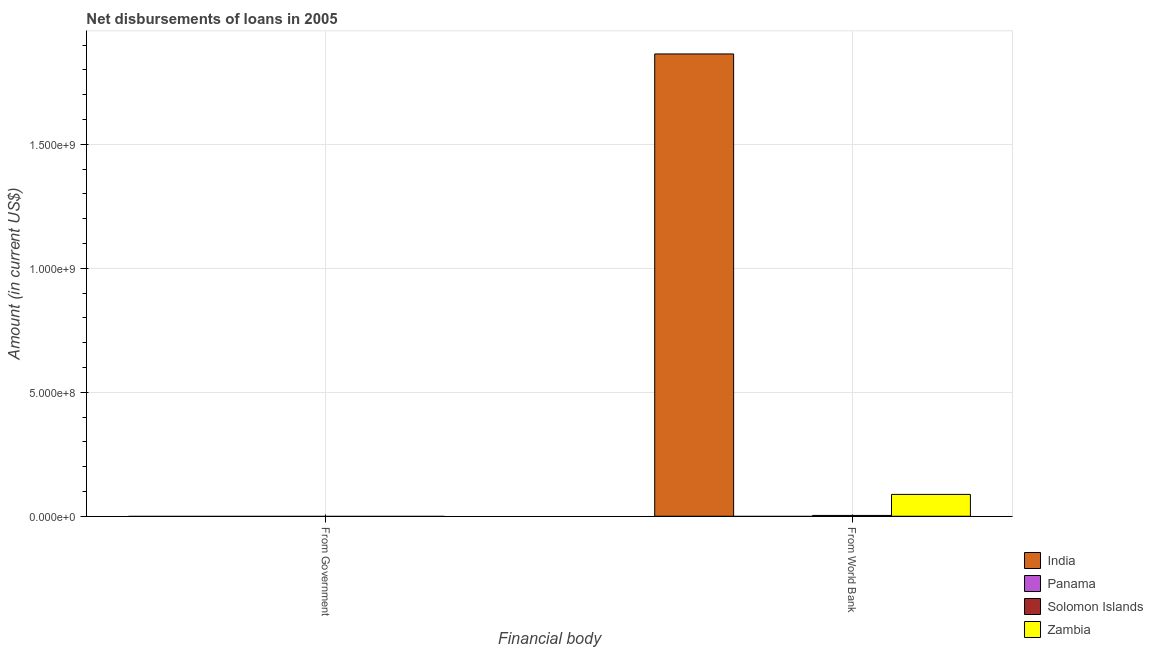How many different coloured bars are there?
Your answer should be compact. 3. Are the number of bars on each tick of the X-axis equal?
Your answer should be very brief. No. How many bars are there on the 1st tick from the left?
Provide a succinct answer. 0. What is the label of the 1st group of bars from the left?
Ensure brevity in your answer.  From Government. Across all countries, what is the maximum net disbursements of loan from world bank?
Offer a terse response. 1.86e+09. What is the difference between the net disbursements of loan from world bank in Solomon Islands and that in Zambia?
Ensure brevity in your answer.  -8.48e+07. What is the difference between the net disbursements of loan from world bank in Panama and the net disbursements of loan from government in Solomon Islands?
Provide a succinct answer. 0. What is the average net disbursements of loan from world bank per country?
Give a very brief answer. 4.89e+08. Is the net disbursements of loan from world bank in India less than that in Zambia?
Offer a very short reply. No. How many bars are there?
Your response must be concise. 3. Are the values on the major ticks of Y-axis written in scientific E-notation?
Offer a terse response. Yes. Does the graph contain any zero values?
Make the answer very short. Yes. How are the legend labels stacked?
Keep it short and to the point. Vertical. What is the title of the graph?
Provide a succinct answer. Net disbursements of loans in 2005. What is the label or title of the X-axis?
Make the answer very short. Financial body. What is the label or title of the Y-axis?
Your answer should be compact. Amount (in current US$). What is the Amount (in current US$) in Panama in From Government?
Your answer should be compact. 0. What is the Amount (in current US$) of Solomon Islands in From Government?
Keep it short and to the point. 0. What is the Amount (in current US$) in Zambia in From Government?
Provide a short and direct response. 0. What is the Amount (in current US$) of India in From World Bank?
Your answer should be compact. 1.86e+09. What is the Amount (in current US$) of Solomon Islands in From World Bank?
Offer a terse response. 3.31e+06. What is the Amount (in current US$) in Zambia in From World Bank?
Provide a short and direct response. 8.81e+07. Across all Financial body, what is the maximum Amount (in current US$) of India?
Your answer should be compact. 1.86e+09. Across all Financial body, what is the maximum Amount (in current US$) in Solomon Islands?
Provide a short and direct response. 3.31e+06. Across all Financial body, what is the maximum Amount (in current US$) of Zambia?
Your answer should be compact. 8.81e+07. Across all Financial body, what is the minimum Amount (in current US$) of India?
Offer a very short reply. 0. Across all Financial body, what is the minimum Amount (in current US$) in Solomon Islands?
Keep it short and to the point. 0. What is the total Amount (in current US$) of India in the graph?
Offer a very short reply. 1.86e+09. What is the total Amount (in current US$) of Solomon Islands in the graph?
Your answer should be very brief. 3.31e+06. What is the total Amount (in current US$) in Zambia in the graph?
Ensure brevity in your answer.  8.81e+07. What is the average Amount (in current US$) in India per Financial body?
Your answer should be very brief. 9.32e+08. What is the average Amount (in current US$) of Solomon Islands per Financial body?
Your answer should be compact. 1.65e+06. What is the average Amount (in current US$) in Zambia per Financial body?
Make the answer very short. 4.41e+07. What is the difference between the Amount (in current US$) in India and Amount (in current US$) in Solomon Islands in From World Bank?
Your answer should be compact. 1.86e+09. What is the difference between the Amount (in current US$) of India and Amount (in current US$) of Zambia in From World Bank?
Ensure brevity in your answer.  1.78e+09. What is the difference between the Amount (in current US$) of Solomon Islands and Amount (in current US$) of Zambia in From World Bank?
Provide a short and direct response. -8.48e+07. What is the difference between the highest and the lowest Amount (in current US$) of India?
Provide a succinct answer. 1.86e+09. What is the difference between the highest and the lowest Amount (in current US$) in Solomon Islands?
Your answer should be compact. 3.31e+06. What is the difference between the highest and the lowest Amount (in current US$) in Zambia?
Provide a short and direct response. 8.81e+07. 